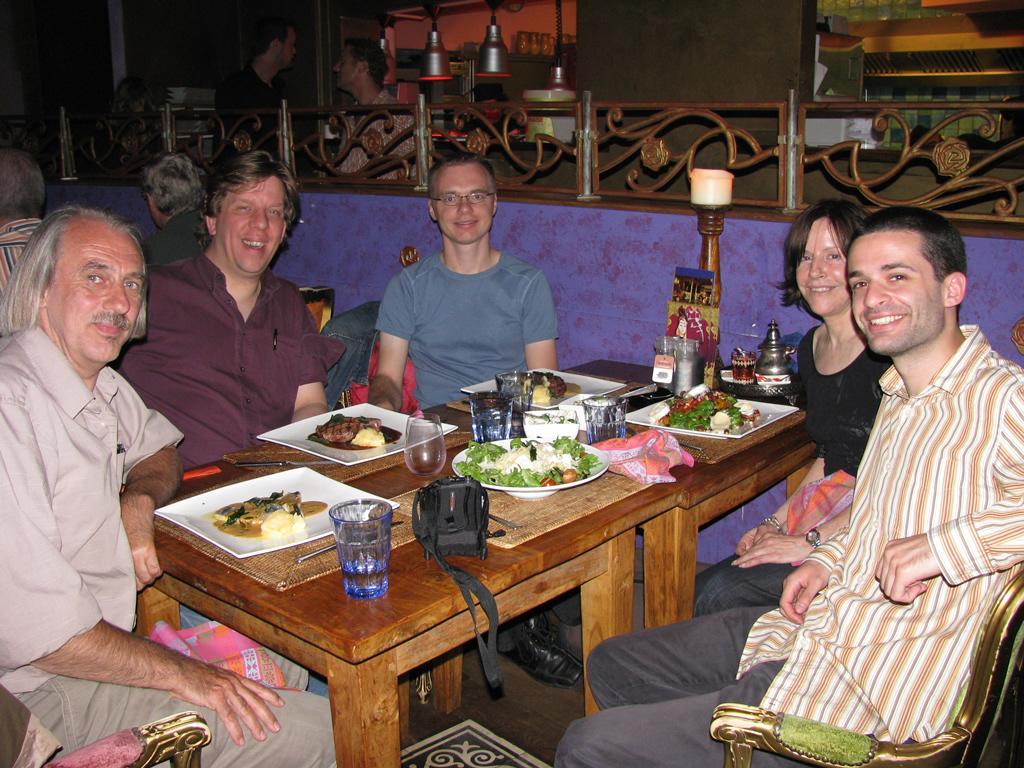How would you summarize this image in a sentence or two? There are group of person sitting on a chair in this picture. In the center there is a table and there are glasses on the table with the plate filled with food. On the table there is a camera, frame, lamp, bottle. The persons sitting on a chair are having smile on their faces. In the background there are persons standing and having conversation with each other, the lamps are hanging and a wall. 